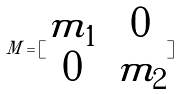<formula> <loc_0><loc_0><loc_500><loc_500>M = [ \begin{matrix} m _ { 1 } & 0 \\ 0 & m _ { 2 } \end{matrix} ]</formula> 